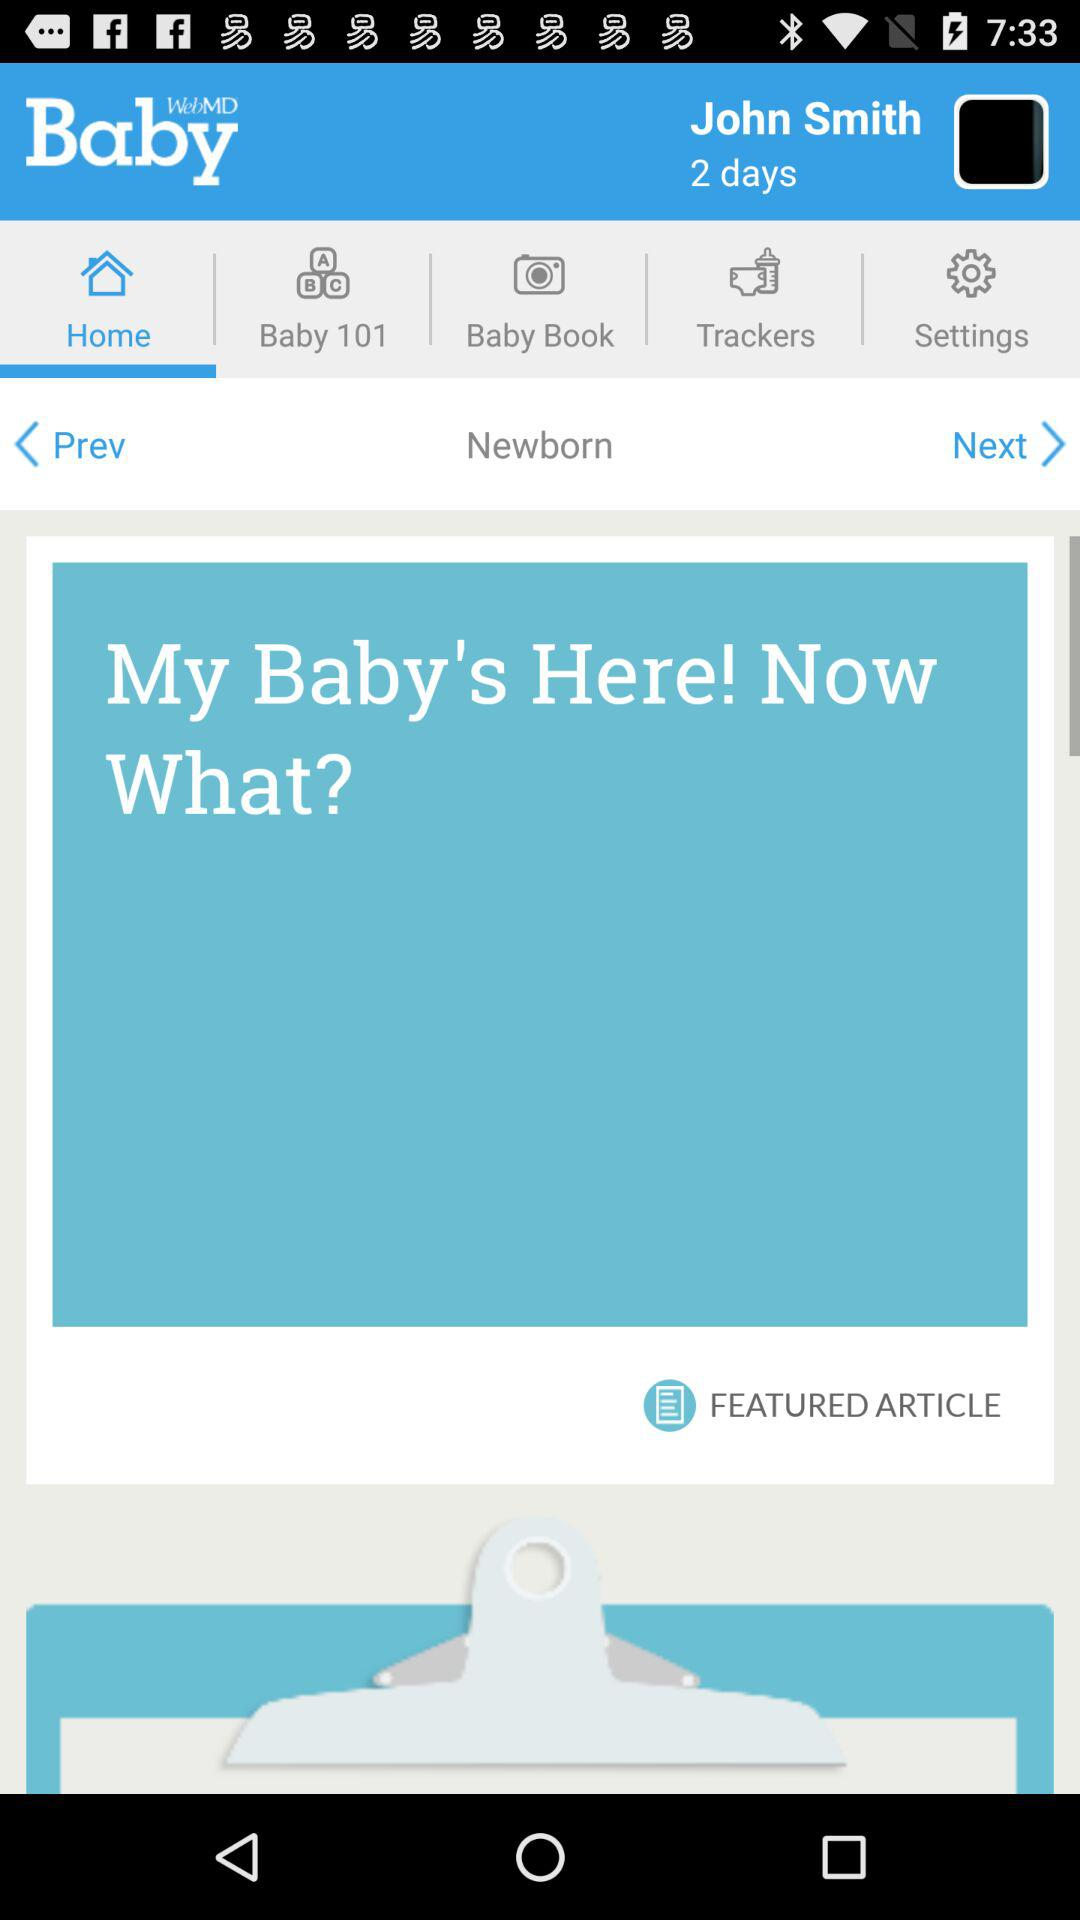Which tab is selected? The selected tab is "Home". 